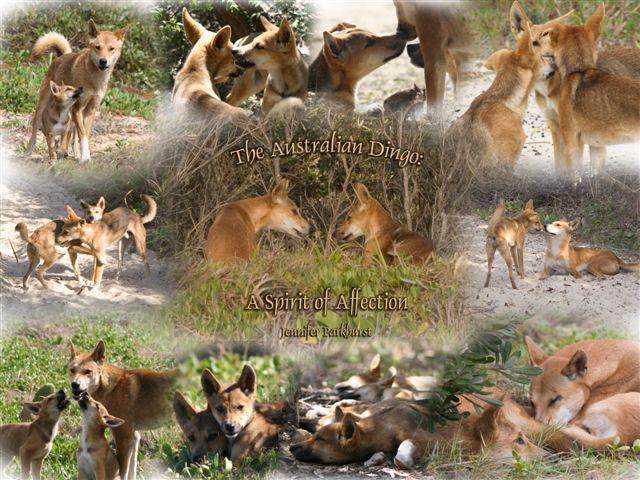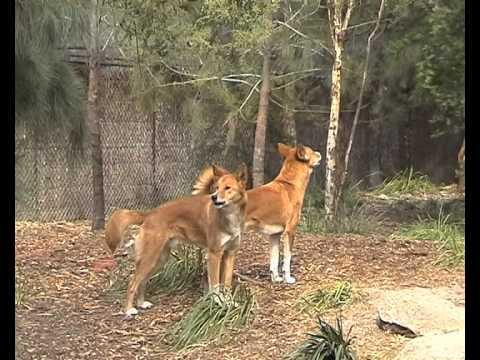The first image is the image on the left, the second image is the image on the right. Evaluate the accuracy of this statement regarding the images: "The dogs in one of the images are near a natural body of water.". Is it true? Answer yes or no. No. The first image is the image on the left, the second image is the image on the right. Analyze the images presented: Is the assertion "Multiple dingos are at the edge of a body of water in one image." valid? Answer yes or no. No. 